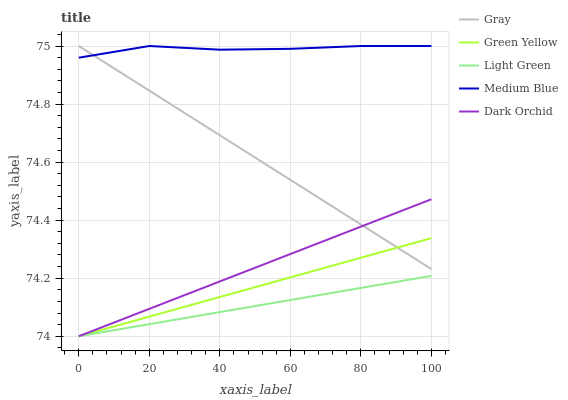Does Light Green have the minimum area under the curve?
Answer yes or no. Yes. Does Medium Blue have the maximum area under the curve?
Answer yes or no. Yes. Does Green Yellow have the minimum area under the curve?
Answer yes or no. No. Does Green Yellow have the maximum area under the curve?
Answer yes or no. No. Is Green Yellow the smoothest?
Answer yes or no. Yes. Is Medium Blue the roughest?
Answer yes or no. Yes. Is Medium Blue the smoothest?
Answer yes or no. No. Is Green Yellow the roughest?
Answer yes or no. No. Does Green Yellow have the lowest value?
Answer yes or no. Yes. Does Medium Blue have the lowest value?
Answer yes or no. No. Does Medium Blue have the highest value?
Answer yes or no. Yes. Does Green Yellow have the highest value?
Answer yes or no. No. Is Green Yellow less than Medium Blue?
Answer yes or no. Yes. Is Gray greater than Light Green?
Answer yes or no. Yes. Does Green Yellow intersect Light Green?
Answer yes or no. Yes. Is Green Yellow less than Light Green?
Answer yes or no. No. Is Green Yellow greater than Light Green?
Answer yes or no. No. Does Green Yellow intersect Medium Blue?
Answer yes or no. No. 